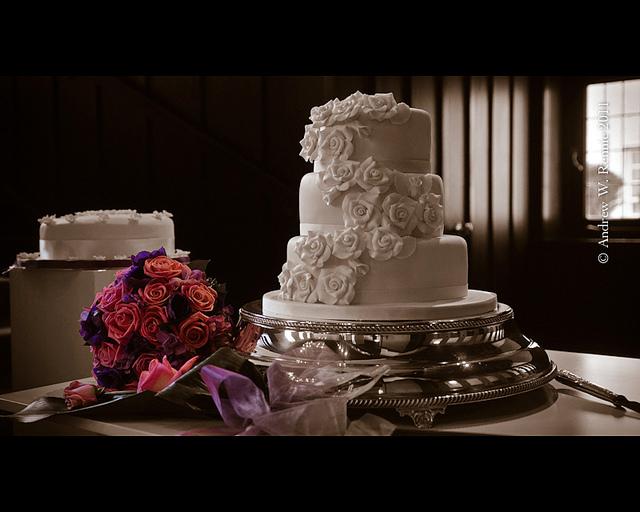What is the cake covered with?
Keep it brief. Frosting. Is someone getting married?
Give a very brief answer. Yes. What two different colors are on the cake?
Quick response, please. 1. How many tiers does the cake have?
Quick response, please. 3. How many tiers are in this cake?
Keep it brief. 3. 